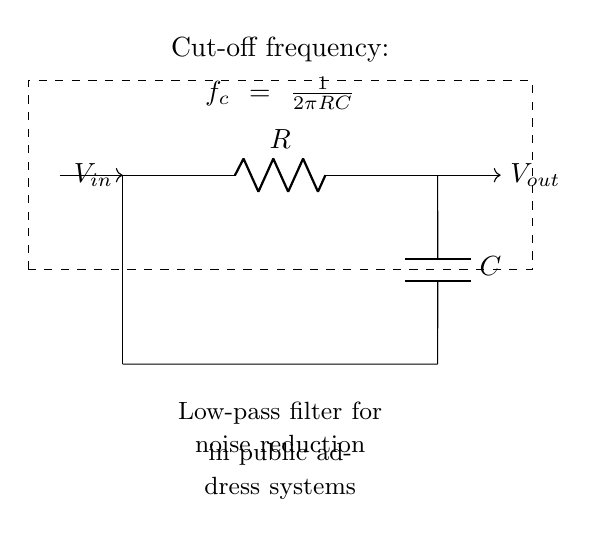What is the role of the resistor in this circuit? The resistor is part of the low-pass filter, controlling the amount of current that flows through the circuit and affects the cut-off frequency.
Answer: Resistor What components are used in this low-pass filter? The low-pass filter is made up of a resistor and a capacitor, which work together to filter out high-frequency noise.
Answer: Resistor and capacitor What does the term cut-off frequency represent in this circuit? The cut-off frequency is the frequency at which the output voltage is reduced to a specific level (usually 70.7% of input), determining the filter's performance on signals.
Answer: Frequency What happens to high-frequency signals in this circuit? High-frequency signals are attenuated or reduced in amplitude, allowing only low-frequency signals to pass through effectively.
Answer: Attenuated How is the cut-off frequency calculated in this circuit? The cut-off frequency is calculated using the formula f_c = 1/(2πRC), where R is the resistance and C is the capacitance, determining the frequency at which the filter starts to attenuate signals.
Answer: 1/(2πRC) What is the output voltage reference in this circuit? The output voltage is taken across the capacitor, which shows the filtered signal after the noise has been reduced by the low-pass filter.
Answer: Across the capacitor 